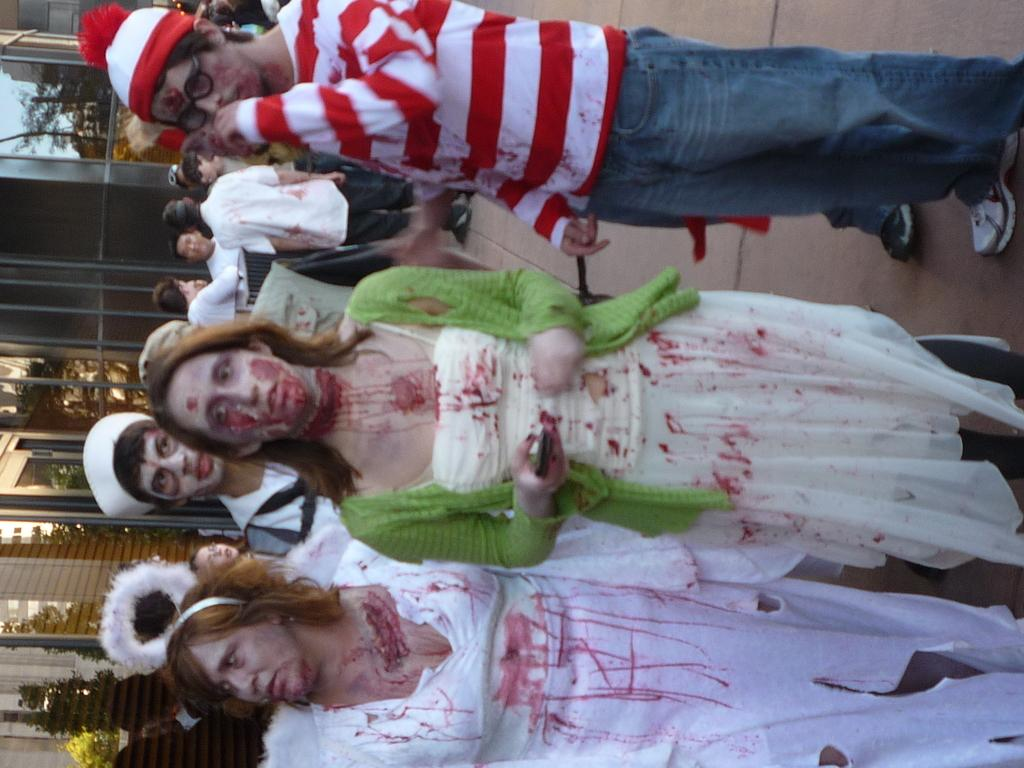Where was the picture taken? The picture was taken outside. What can be seen in the center of the image? There is a group of people standing in the center of the image. What surface are the people standing on? The people are standing on the ground. What is visible in the background of the image? There is a sky, trees, and buildings visible in the background of the image. What type of record can be seen in the hands of the people in the image? There is no record present in the image; it features a group of people standing outside. What toys are the people playing with in the image? There are no toys visible in the image; the people are simply standing. 